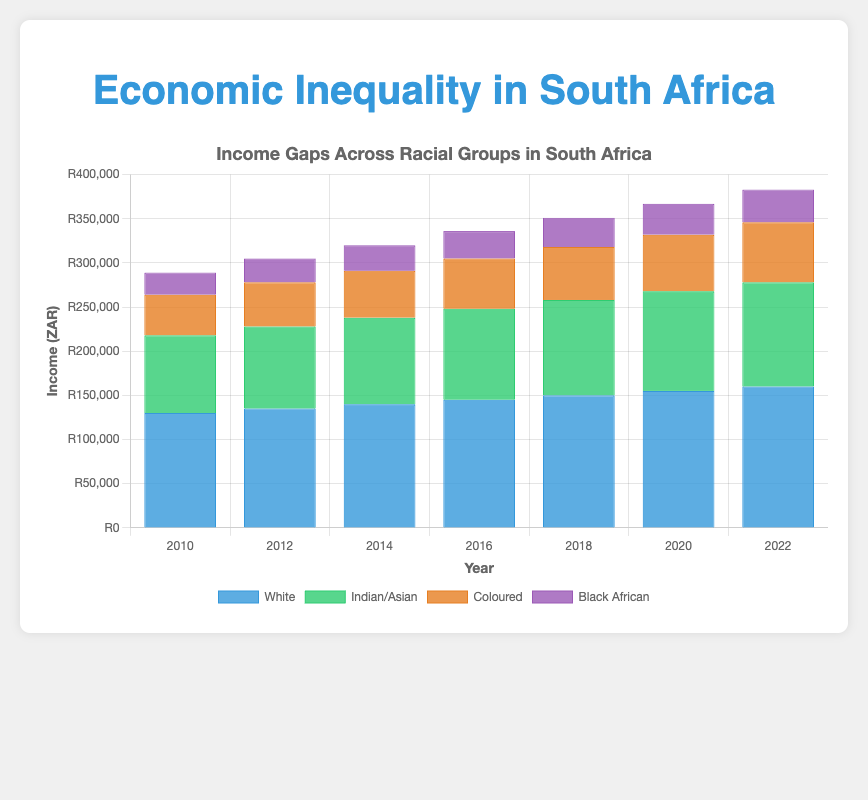Which racial group had the highest average income in 2022? To find the average income for each racial group in 2022, one just needs to look at the bar representing the year 2022 in the chart. The 'White' group has the highest bar at 160,000 ZAR.
Answer: White What is the difference in income between the White and Black African groups in 2022? Referring to the year 2022, the income for the White group is 160,000 ZAR and for the Black African group, it is 37,000 ZAR. The difference is calculated as 160,000 - 37,000 = 123,000 ZAR.
Answer: 123,000 ZAR How has the income for the Indian/Asian group changed from 2010 to 2014? The income for the Indian/Asian group in 2010 is 88,000 ZAR and in 2014 it is 98,000 ZAR. The change is 98,000 - 88,000 = 10,000 ZAR.
Answer: Increased by 10,000 ZAR Which years had the lowest income for the Black African group? Observing the chart, the lowest bar for the Black African group corresponds to the year 2010 with an income of 25,000 ZAR.
Answer: 2010 Compare the income growth rate from 2010 to 2022 for both the Coloured and Black African groups. Which grew faster? From 2010 to 2022, the Coloured group income grows from 46,000 to 68,000 ZAR (a growth of 22,000 ZAR), and the Black African group income grows from 25,000 to 37,000 ZAR (a growth of 12,000 ZAR). The Coloured group has a higher growth rate.
Answer: Coloured group What is the combined income of the Coloured group in the years 2018 and 2020? The income for the Coloured group in 2018 is 60,000 ZAR and in 2020 it is 64,000 ZAR. The combined income is 60,000 + 64,000 = 124,000 ZAR.
Answer: 124,000 ZAR Which racial group has shown a steady increase in income every two years from 2010 to 2022? Observing the bars across all years for each racial group, all groups show a steady increase, but the White group consistently has higher values each period.
Answer: White What's the average income for the Indian/Asian group from 2010 to 2022? Summing the values for the Indian/Asian group across all years: 88,000 + 93,000 + 98,000 + 103,000 + 108,000 + 113,000 + 118,000 = 721,000 ZAR. The average is 721,000 / 7 = 103,000 ZAR.
Answer: 103,000 ZAR Which racial group had the lowest rate of increase from 2010 to 2022? By checking the increase in income for each group between 2010 and 2022, the Black African group had the lowest increase: from 25,000 to 37,000 ZAR (an increase of 12,000 ZAR).
Answer: Black African 